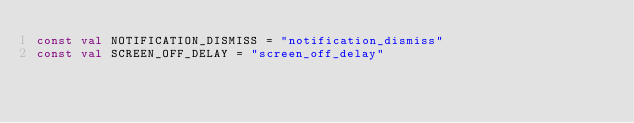Convert code to text. <code><loc_0><loc_0><loc_500><loc_500><_Kotlin_>const val NOTIFICATION_DISMISS = "notification_dismiss"
const val SCREEN_OFF_DELAY = "screen_off_delay"
</code> 